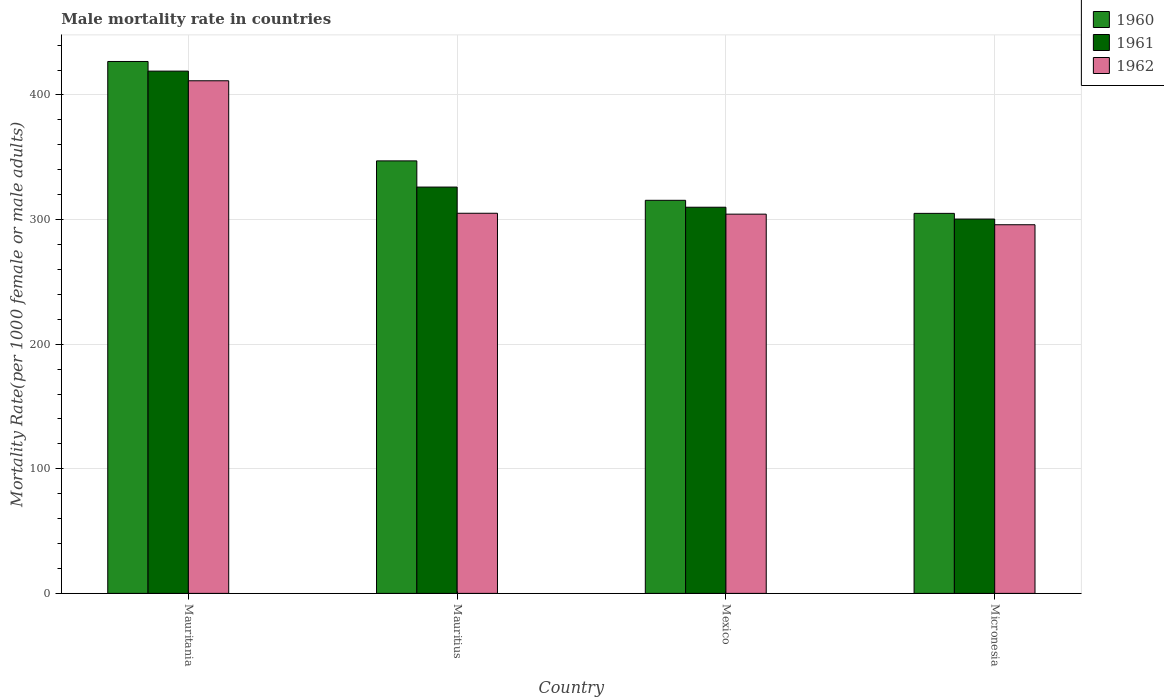How many groups of bars are there?
Provide a succinct answer. 4. Are the number of bars per tick equal to the number of legend labels?
Offer a very short reply. Yes. Are the number of bars on each tick of the X-axis equal?
Your answer should be very brief. Yes. How many bars are there on the 3rd tick from the left?
Your answer should be very brief. 3. What is the label of the 2nd group of bars from the left?
Your answer should be compact. Mauritius. In how many cases, is the number of bars for a given country not equal to the number of legend labels?
Your answer should be compact. 0. What is the male mortality rate in 1961 in Mexico?
Provide a succinct answer. 309.9. Across all countries, what is the maximum male mortality rate in 1961?
Keep it short and to the point. 419.13. Across all countries, what is the minimum male mortality rate in 1960?
Provide a short and direct response. 304.97. In which country was the male mortality rate in 1960 maximum?
Make the answer very short. Mauritania. In which country was the male mortality rate in 1960 minimum?
Make the answer very short. Micronesia. What is the total male mortality rate in 1962 in the graph?
Provide a succinct answer. 1316.64. What is the difference between the male mortality rate in 1960 in Mauritania and that in Mexico?
Your answer should be very brief. 111.42. What is the difference between the male mortality rate in 1962 in Micronesia and the male mortality rate in 1961 in Mauritius?
Your answer should be very brief. -30.23. What is the average male mortality rate in 1960 per country?
Offer a very short reply. 348.6. What is the difference between the male mortality rate of/in 1962 and male mortality rate of/in 1961 in Mauritius?
Provide a succinct answer. -21.02. What is the ratio of the male mortality rate in 1961 in Mauritius to that in Micronesia?
Offer a very short reply. 1.09. Is the difference between the male mortality rate in 1962 in Mauritius and Mexico greater than the difference between the male mortality rate in 1961 in Mauritius and Mexico?
Provide a succinct answer. No. What is the difference between the highest and the second highest male mortality rate in 1961?
Provide a succinct answer. 109.23. What is the difference between the highest and the lowest male mortality rate in 1960?
Keep it short and to the point. 121.91. In how many countries, is the male mortality rate in 1962 greater than the average male mortality rate in 1962 taken over all countries?
Offer a terse response. 1. Is the sum of the male mortality rate in 1961 in Mexico and Micronesia greater than the maximum male mortality rate in 1962 across all countries?
Provide a short and direct response. Yes. What does the 2nd bar from the left in Mauritius represents?
Your answer should be compact. 1961. What does the 1st bar from the right in Mauritius represents?
Your answer should be very brief. 1962. Are all the bars in the graph horizontal?
Give a very brief answer. No. How many countries are there in the graph?
Your answer should be very brief. 4. Are the values on the major ticks of Y-axis written in scientific E-notation?
Your answer should be compact. No. Does the graph contain grids?
Provide a short and direct response. Yes. Where does the legend appear in the graph?
Provide a short and direct response. Top right. What is the title of the graph?
Offer a terse response. Male mortality rate in countries. Does "1978" appear as one of the legend labels in the graph?
Offer a very short reply. No. What is the label or title of the Y-axis?
Provide a short and direct response. Mortality Rate(per 1000 female or male adults). What is the Mortality Rate(per 1000 female or male adults) in 1960 in Mauritania?
Give a very brief answer. 426.88. What is the Mortality Rate(per 1000 female or male adults) in 1961 in Mauritania?
Your answer should be compact. 419.13. What is the Mortality Rate(per 1000 female or male adults) in 1962 in Mauritania?
Your answer should be very brief. 411.38. What is the Mortality Rate(per 1000 female or male adults) of 1960 in Mauritius?
Your response must be concise. 347.09. What is the Mortality Rate(per 1000 female or male adults) of 1961 in Mauritius?
Offer a very short reply. 326.08. What is the Mortality Rate(per 1000 female or male adults) in 1962 in Mauritius?
Offer a terse response. 305.06. What is the Mortality Rate(per 1000 female or male adults) of 1960 in Mexico?
Offer a very short reply. 315.46. What is the Mortality Rate(per 1000 female or male adults) in 1961 in Mexico?
Your response must be concise. 309.9. What is the Mortality Rate(per 1000 female or male adults) in 1962 in Mexico?
Offer a very short reply. 304.34. What is the Mortality Rate(per 1000 female or male adults) of 1960 in Micronesia?
Your answer should be compact. 304.97. What is the Mortality Rate(per 1000 female or male adults) in 1961 in Micronesia?
Your answer should be very brief. 300.41. What is the Mortality Rate(per 1000 female or male adults) in 1962 in Micronesia?
Keep it short and to the point. 295.85. Across all countries, what is the maximum Mortality Rate(per 1000 female or male adults) of 1960?
Your answer should be very brief. 426.88. Across all countries, what is the maximum Mortality Rate(per 1000 female or male adults) of 1961?
Provide a succinct answer. 419.13. Across all countries, what is the maximum Mortality Rate(per 1000 female or male adults) of 1962?
Make the answer very short. 411.38. Across all countries, what is the minimum Mortality Rate(per 1000 female or male adults) in 1960?
Your answer should be compact. 304.97. Across all countries, what is the minimum Mortality Rate(per 1000 female or male adults) in 1961?
Ensure brevity in your answer.  300.41. Across all countries, what is the minimum Mortality Rate(per 1000 female or male adults) of 1962?
Provide a short and direct response. 295.85. What is the total Mortality Rate(per 1000 female or male adults) of 1960 in the graph?
Make the answer very short. 1394.4. What is the total Mortality Rate(per 1000 female or male adults) in 1961 in the graph?
Offer a very short reply. 1355.52. What is the total Mortality Rate(per 1000 female or male adults) of 1962 in the graph?
Your answer should be compact. 1316.64. What is the difference between the Mortality Rate(per 1000 female or male adults) of 1960 in Mauritania and that in Mauritius?
Your answer should be very brief. 79.78. What is the difference between the Mortality Rate(per 1000 female or male adults) in 1961 in Mauritania and that in Mauritius?
Make the answer very short. 93.05. What is the difference between the Mortality Rate(per 1000 female or male adults) of 1962 in Mauritania and that in Mauritius?
Your answer should be compact. 106.32. What is the difference between the Mortality Rate(per 1000 female or male adults) of 1960 in Mauritania and that in Mexico?
Your answer should be compact. 111.42. What is the difference between the Mortality Rate(per 1000 female or male adults) in 1961 in Mauritania and that in Mexico?
Provide a short and direct response. 109.23. What is the difference between the Mortality Rate(per 1000 female or male adults) in 1962 in Mauritania and that in Mexico?
Provide a short and direct response. 107.04. What is the difference between the Mortality Rate(per 1000 female or male adults) in 1960 in Mauritania and that in Micronesia?
Ensure brevity in your answer.  121.91. What is the difference between the Mortality Rate(per 1000 female or male adults) of 1961 in Mauritania and that in Micronesia?
Your answer should be very brief. 118.72. What is the difference between the Mortality Rate(per 1000 female or male adults) in 1962 in Mauritania and that in Micronesia?
Your answer should be compact. 115.53. What is the difference between the Mortality Rate(per 1000 female or male adults) of 1960 in Mauritius and that in Mexico?
Keep it short and to the point. 31.64. What is the difference between the Mortality Rate(per 1000 female or male adults) of 1961 in Mauritius and that in Mexico?
Offer a very short reply. 16.18. What is the difference between the Mortality Rate(per 1000 female or male adults) of 1962 in Mauritius and that in Mexico?
Offer a terse response. 0.72. What is the difference between the Mortality Rate(per 1000 female or male adults) of 1960 in Mauritius and that in Micronesia?
Your answer should be compact. 42.12. What is the difference between the Mortality Rate(per 1000 female or male adults) in 1961 in Mauritius and that in Micronesia?
Your answer should be compact. 25.67. What is the difference between the Mortality Rate(per 1000 female or male adults) in 1962 in Mauritius and that in Micronesia?
Ensure brevity in your answer.  9.21. What is the difference between the Mortality Rate(per 1000 female or male adults) of 1960 in Mexico and that in Micronesia?
Ensure brevity in your answer.  10.49. What is the difference between the Mortality Rate(per 1000 female or male adults) in 1961 in Mexico and that in Micronesia?
Provide a short and direct response. 9.49. What is the difference between the Mortality Rate(per 1000 female or male adults) in 1962 in Mexico and that in Micronesia?
Provide a succinct answer. 8.49. What is the difference between the Mortality Rate(per 1000 female or male adults) of 1960 in Mauritania and the Mortality Rate(per 1000 female or male adults) of 1961 in Mauritius?
Keep it short and to the point. 100.8. What is the difference between the Mortality Rate(per 1000 female or male adults) in 1960 in Mauritania and the Mortality Rate(per 1000 female or male adults) in 1962 in Mauritius?
Provide a short and direct response. 121.81. What is the difference between the Mortality Rate(per 1000 female or male adults) in 1961 in Mauritania and the Mortality Rate(per 1000 female or male adults) in 1962 in Mauritius?
Offer a very short reply. 114.07. What is the difference between the Mortality Rate(per 1000 female or male adults) in 1960 in Mauritania and the Mortality Rate(per 1000 female or male adults) in 1961 in Mexico?
Make the answer very short. 116.97. What is the difference between the Mortality Rate(per 1000 female or male adults) in 1960 in Mauritania and the Mortality Rate(per 1000 female or male adults) in 1962 in Mexico?
Your answer should be very brief. 122.53. What is the difference between the Mortality Rate(per 1000 female or male adults) of 1961 in Mauritania and the Mortality Rate(per 1000 female or male adults) of 1962 in Mexico?
Ensure brevity in your answer.  114.78. What is the difference between the Mortality Rate(per 1000 female or male adults) in 1960 in Mauritania and the Mortality Rate(per 1000 female or male adults) in 1961 in Micronesia?
Provide a succinct answer. 126.47. What is the difference between the Mortality Rate(per 1000 female or male adults) of 1960 in Mauritania and the Mortality Rate(per 1000 female or male adults) of 1962 in Micronesia?
Offer a very short reply. 131.03. What is the difference between the Mortality Rate(per 1000 female or male adults) in 1961 in Mauritania and the Mortality Rate(per 1000 female or male adults) in 1962 in Micronesia?
Give a very brief answer. 123.28. What is the difference between the Mortality Rate(per 1000 female or male adults) in 1960 in Mauritius and the Mortality Rate(per 1000 female or male adults) in 1961 in Mexico?
Your response must be concise. 37.19. What is the difference between the Mortality Rate(per 1000 female or male adults) of 1960 in Mauritius and the Mortality Rate(per 1000 female or male adults) of 1962 in Mexico?
Give a very brief answer. 42.75. What is the difference between the Mortality Rate(per 1000 female or male adults) of 1961 in Mauritius and the Mortality Rate(per 1000 female or male adults) of 1962 in Mexico?
Your response must be concise. 21.73. What is the difference between the Mortality Rate(per 1000 female or male adults) in 1960 in Mauritius and the Mortality Rate(per 1000 female or male adults) in 1961 in Micronesia?
Your answer should be very brief. 46.68. What is the difference between the Mortality Rate(per 1000 female or male adults) of 1960 in Mauritius and the Mortality Rate(per 1000 female or male adults) of 1962 in Micronesia?
Give a very brief answer. 51.24. What is the difference between the Mortality Rate(per 1000 female or male adults) of 1961 in Mauritius and the Mortality Rate(per 1000 female or male adults) of 1962 in Micronesia?
Make the answer very short. 30.23. What is the difference between the Mortality Rate(per 1000 female or male adults) in 1960 in Mexico and the Mortality Rate(per 1000 female or male adults) in 1961 in Micronesia?
Give a very brief answer. 15.05. What is the difference between the Mortality Rate(per 1000 female or male adults) of 1960 in Mexico and the Mortality Rate(per 1000 female or male adults) of 1962 in Micronesia?
Provide a short and direct response. 19.61. What is the difference between the Mortality Rate(per 1000 female or male adults) in 1961 in Mexico and the Mortality Rate(per 1000 female or male adults) in 1962 in Micronesia?
Your answer should be compact. 14.05. What is the average Mortality Rate(per 1000 female or male adults) of 1960 per country?
Offer a terse response. 348.6. What is the average Mortality Rate(per 1000 female or male adults) of 1961 per country?
Offer a terse response. 338.88. What is the average Mortality Rate(per 1000 female or male adults) of 1962 per country?
Your answer should be very brief. 329.16. What is the difference between the Mortality Rate(per 1000 female or male adults) in 1960 and Mortality Rate(per 1000 female or male adults) in 1961 in Mauritania?
Make the answer very short. 7.75. What is the difference between the Mortality Rate(per 1000 female or male adults) in 1960 and Mortality Rate(per 1000 female or male adults) in 1962 in Mauritania?
Your answer should be very brief. 15.49. What is the difference between the Mortality Rate(per 1000 female or male adults) of 1961 and Mortality Rate(per 1000 female or male adults) of 1962 in Mauritania?
Your response must be concise. 7.75. What is the difference between the Mortality Rate(per 1000 female or male adults) in 1960 and Mortality Rate(per 1000 female or male adults) in 1961 in Mauritius?
Offer a very short reply. 21.02. What is the difference between the Mortality Rate(per 1000 female or male adults) in 1960 and Mortality Rate(per 1000 female or male adults) in 1962 in Mauritius?
Provide a succinct answer. 42.03. What is the difference between the Mortality Rate(per 1000 female or male adults) in 1961 and Mortality Rate(per 1000 female or male adults) in 1962 in Mauritius?
Provide a short and direct response. 21.02. What is the difference between the Mortality Rate(per 1000 female or male adults) of 1960 and Mortality Rate(per 1000 female or male adults) of 1961 in Mexico?
Your answer should be compact. 5.56. What is the difference between the Mortality Rate(per 1000 female or male adults) in 1960 and Mortality Rate(per 1000 female or male adults) in 1962 in Mexico?
Make the answer very short. 11.11. What is the difference between the Mortality Rate(per 1000 female or male adults) in 1961 and Mortality Rate(per 1000 female or male adults) in 1962 in Mexico?
Make the answer very short. 5.56. What is the difference between the Mortality Rate(per 1000 female or male adults) of 1960 and Mortality Rate(per 1000 female or male adults) of 1961 in Micronesia?
Provide a short and direct response. 4.56. What is the difference between the Mortality Rate(per 1000 female or male adults) of 1960 and Mortality Rate(per 1000 female or male adults) of 1962 in Micronesia?
Offer a very short reply. 9.12. What is the difference between the Mortality Rate(per 1000 female or male adults) in 1961 and Mortality Rate(per 1000 female or male adults) in 1962 in Micronesia?
Offer a terse response. 4.56. What is the ratio of the Mortality Rate(per 1000 female or male adults) in 1960 in Mauritania to that in Mauritius?
Your answer should be compact. 1.23. What is the ratio of the Mortality Rate(per 1000 female or male adults) of 1961 in Mauritania to that in Mauritius?
Your answer should be very brief. 1.29. What is the ratio of the Mortality Rate(per 1000 female or male adults) in 1962 in Mauritania to that in Mauritius?
Keep it short and to the point. 1.35. What is the ratio of the Mortality Rate(per 1000 female or male adults) of 1960 in Mauritania to that in Mexico?
Ensure brevity in your answer.  1.35. What is the ratio of the Mortality Rate(per 1000 female or male adults) in 1961 in Mauritania to that in Mexico?
Provide a short and direct response. 1.35. What is the ratio of the Mortality Rate(per 1000 female or male adults) in 1962 in Mauritania to that in Mexico?
Your answer should be very brief. 1.35. What is the ratio of the Mortality Rate(per 1000 female or male adults) of 1960 in Mauritania to that in Micronesia?
Your answer should be very brief. 1.4. What is the ratio of the Mortality Rate(per 1000 female or male adults) of 1961 in Mauritania to that in Micronesia?
Your answer should be very brief. 1.4. What is the ratio of the Mortality Rate(per 1000 female or male adults) of 1962 in Mauritania to that in Micronesia?
Provide a short and direct response. 1.39. What is the ratio of the Mortality Rate(per 1000 female or male adults) in 1960 in Mauritius to that in Mexico?
Your answer should be compact. 1.1. What is the ratio of the Mortality Rate(per 1000 female or male adults) of 1961 in Mauritius to that in Mexico?
Your response must be concise. 1.05. What is the ratio of the Mortality Rate(per 1000 female or male adults) of 1962 in Mauritius to that in Mexico?
Provide a short and direct response. 1. What is the ratio of the Mortality Rate(per 1000 female or male adults) in 1960 in Mauritius to that in Micronesia?
Ensure brevity in your answer.  1.14. What is the ratio of the Mortality Rate(per 1000 female or male adults) of 1961 in Mauritius to that in Micronesia?
Offer a very short reply. 1.09. What is the ratio of the Mortality Rate(per 1000 female or male adults) in 1962 in Mauritius to that in Micronesia?
Provide a succinct answer. 1.03. What is the ratio of the Mortality Rate(per 1000 female or male adults) of 1960 in Mexico to that in Micronesia?
Ensure brevity in your answer.  1.03. What is the ratio of the Mortality Rate(per 1000 female or male adults) in 1961 in Mexico to that in Micronesia?
Ensure brevity in your answer.  1.03. What is the ratio of the Mortality Rate(per 1000 female or male adults) of 1962 in Mexico to that in Micronesia?
Offer a very short reply. 1.03. What is the difference between the highest and the second highest Mortality Rate(per 1000 female or male adults) of 1960?
Provide a short and direct response. 79.78. What is the difference between the highest and the second highest Mortality Rate(per 1000 female or male adults) of 1961?
Make the answer very short. 93.05. What is the difference between the highest and the second highest Mortality Rate(per 1000 female or male adults) of 1962?
Keep it short and to the point. 106.32. What is the difference between the highest and the lowest Mortality Rate(per 1000 female or male adults) of 1960?
Provide a succinct answer. 121.91. What is the difference between the highest and the lowest Mortality Rate(per 1000 female or male adults) in 1961?
Your answer should be very brief. 118.72. What is the difference between the highest and the lowest Mortality Rate(per 1000 female or male adults) in 1962?
Offer a very short reply. 115.53. 